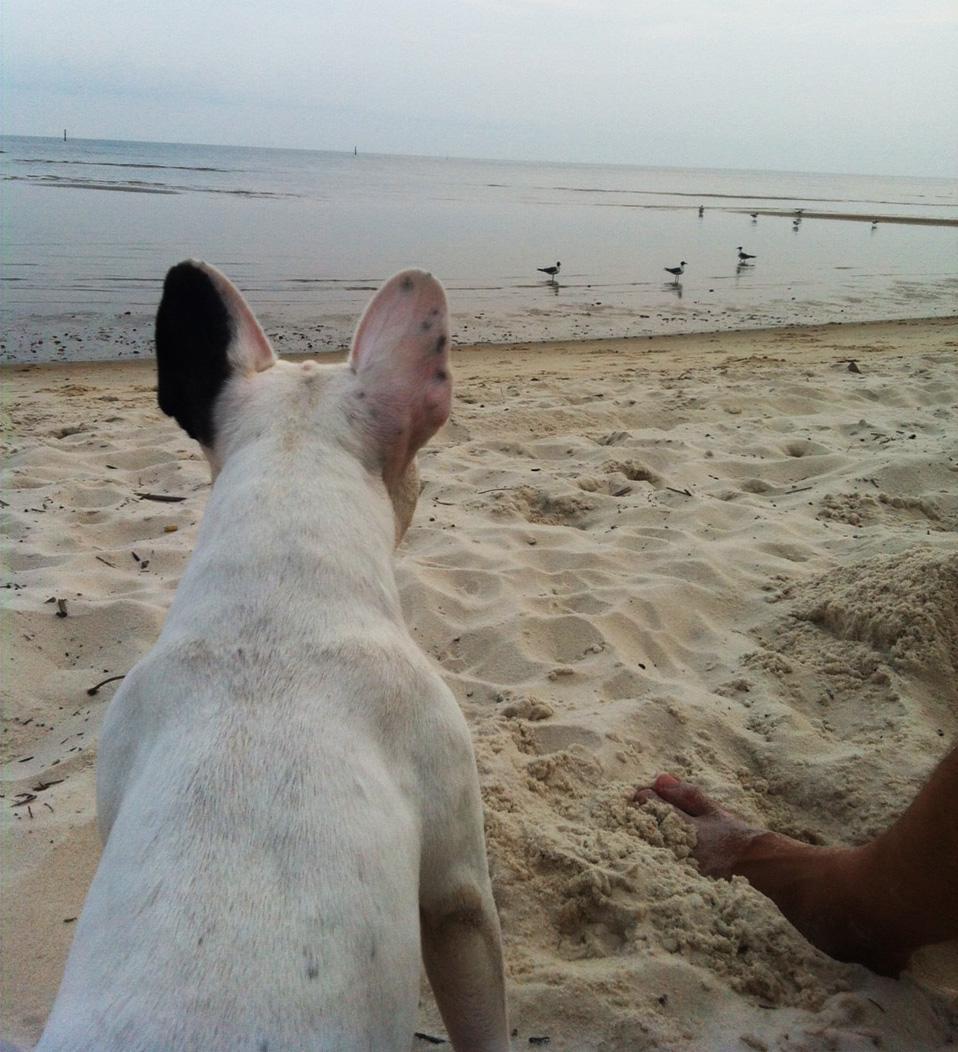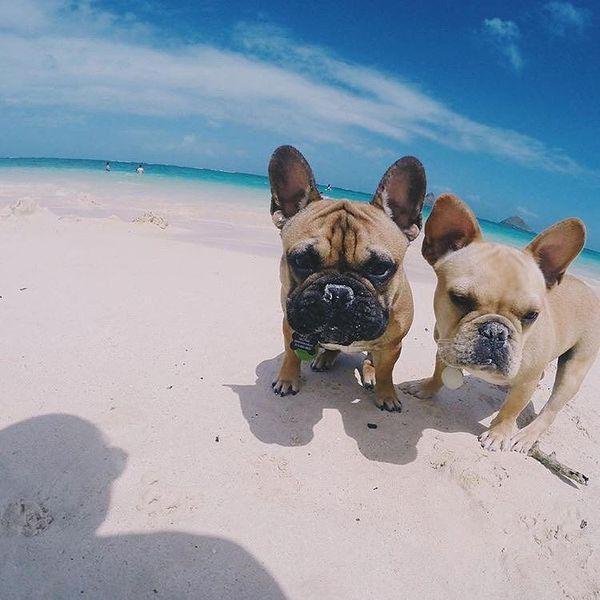The first image is the image on the left, the second image is the image on the right. Considering the images on both sides, is "Four dogs are on the beach with no human visible." valid? Answer yes or no. No. The first image is the image on the left, the second image is the image on the right. Considering the images on both sides, is "An image shows a brownish dog in profile, wearing a harness." valid? Answer yes or no. No. 